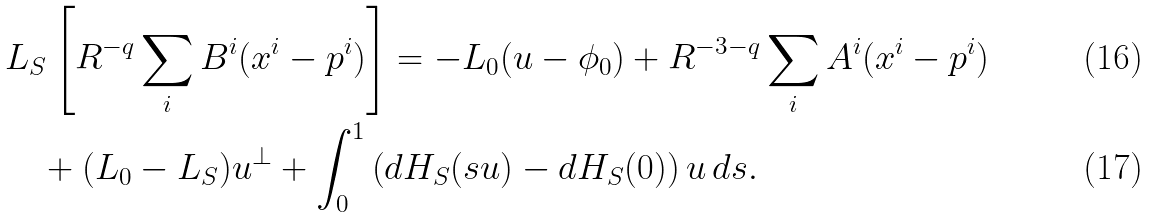Convert formula to latex. <formula><loc_0><loc_0><loc_500><loc_500>& L _ { S } \left [ R ^ { - q } \sum _ { i } B ^ { i } ( x ^ { i } - p ^ { i } ) \right ] = - L _ { 0 } ( u - \phi _ { 0 } ) + R ^ { - 3 - q } \sum _ { i } A ^ { i } ( x ^ { i } - p ^ { i } ) \\ & \quad + ( L _ { 0 } - L _ { S } ) u ^ { \perp } + \int _ { 0 } ^ { 1 } \left ( d H _ { S } ( s u ) - d H _ { S } ( 0 ) \right ) u \, d s .</formula> 